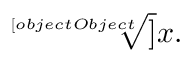Convert formula to latex. <formula><loc_0><loc_0><loc_500><loc_500>{ \sqrt { [ } [ o b j e c t O b j e c t ] ] { x } } .</formula> 